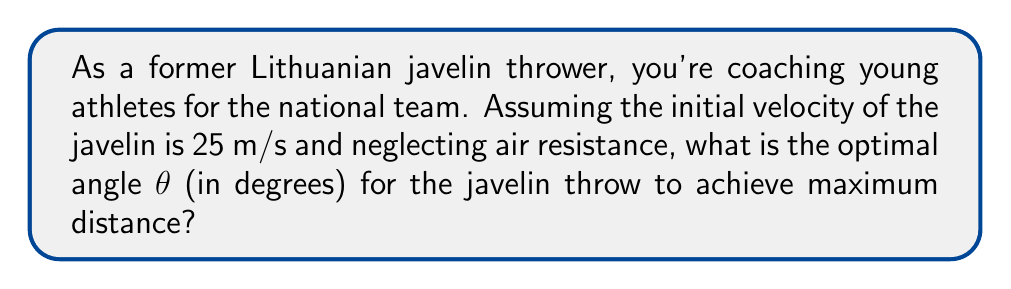What is the answer to this math problem? Let's approach this step-by-step:

1) The trajectory of a javelin (neglecting air resistance) follows a parabolic path described by the equations of motion for projectile motion.

2) The range (R) of a projectile launched at an angle θ with initial velocity v₀ is given by:

   $$R = \frac{v_0^2 \sin(2\theta)}{g}$$

   where g is the acceleration due to gravity (9.8 m/s²).

3) To find the maximum range, we need to maximize sin(2θ). This occurs when 2θ = 90°, or when θ = 45°.

4) We can prove this mathematically by differentiating R with respect to θ and setting it to zero:

   $$\frac{dR}{d\theta} = \frac{2v_0^2 \cos(2\theta)}{g} = 0$$

   This is true when cos(2θ) = 0, which occurs when 2θ = 90°, or θ = 45°.

5) Therefore, the optimal angle for maximum distance in ideal conditions is always 45°.

6) In real-world conditions, factors like air resistance and the aerodynamics of the javelin slightly reduce this angle to about 43°, but for this idealized problem, we'll use 45°.
Answer: 45° 